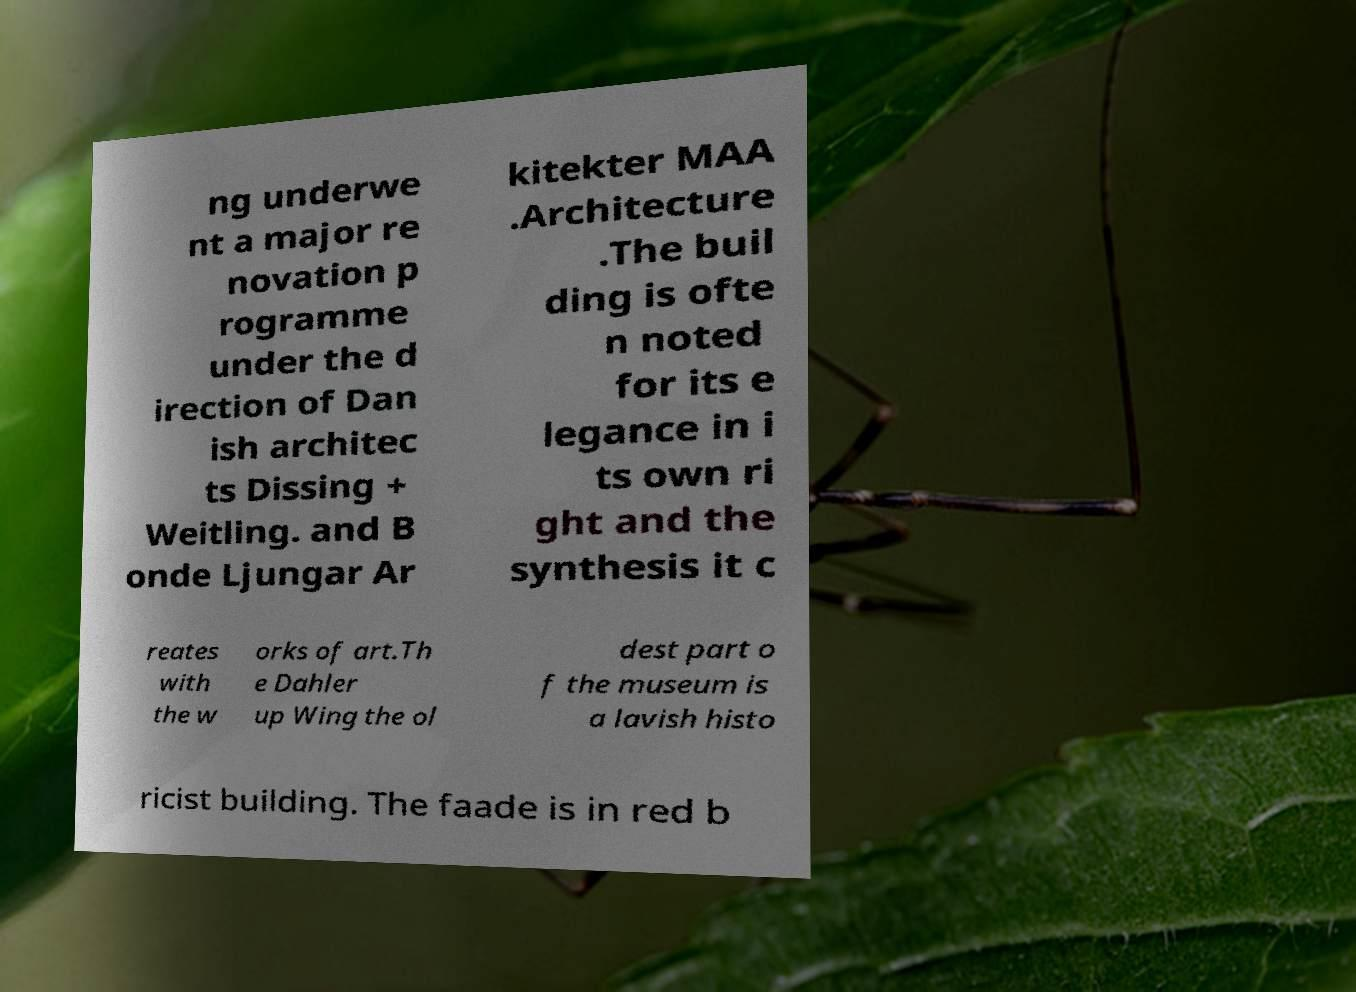Can you accurately transcribe the text from the provided image for me? ng underwe nt a major re novation p rogramme under the d irection of Dan ish architec ts Dissing + Weitling. and B onde Ljungar Ar kitekter MAA .Architecture .The buil ding is ofte n noted for its e legance in i ts own ri ght and the synthesis it c reates with the w orks of art.Th e Dahler up Wing the ol dest part o f the museum is a lavish histo ricist building. The faade is in red b 